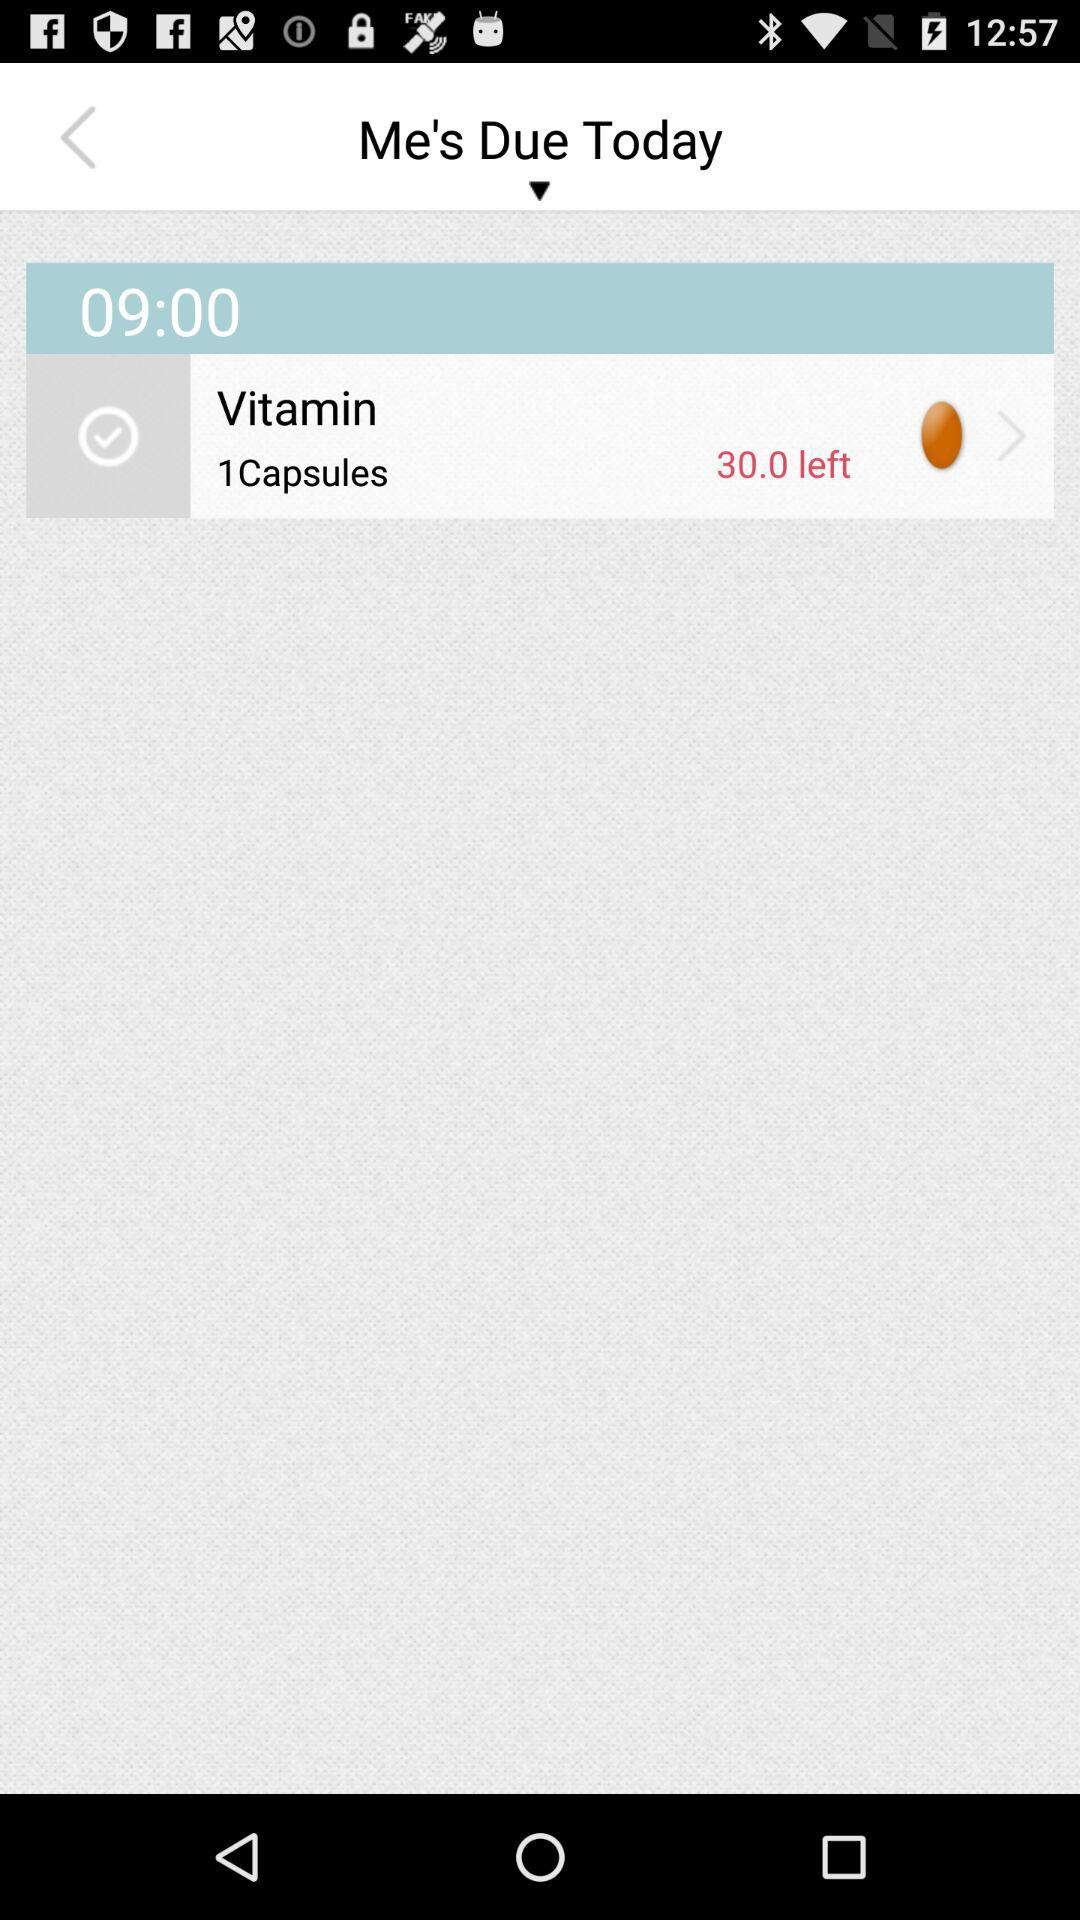How many vitamin capsules are left? The number of vitamin capsules left is 30. 